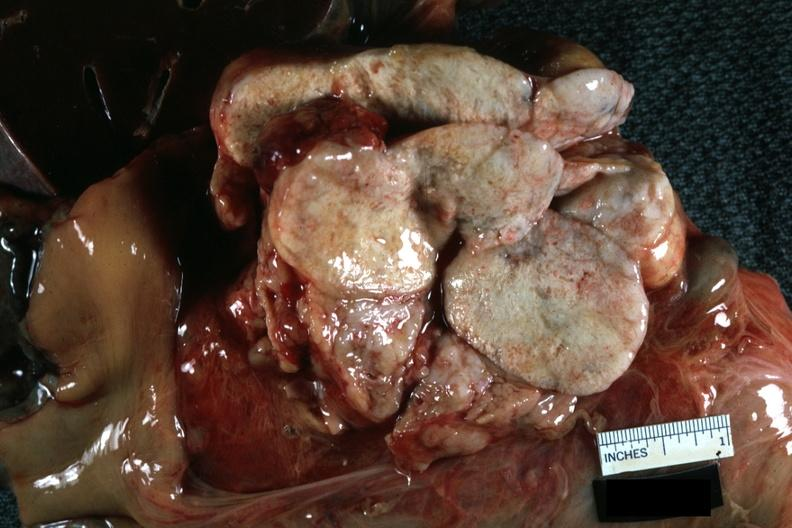what does this image show?
Answer the question using a single word or phrase. Nodes at tail of pancreas natural color close-up massive replacement by metastatic lung carcinoma 